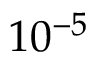<formula> <loc_0><loc_0><loc_500><loc_500>1 0 ^ { - 5 }</formula> 